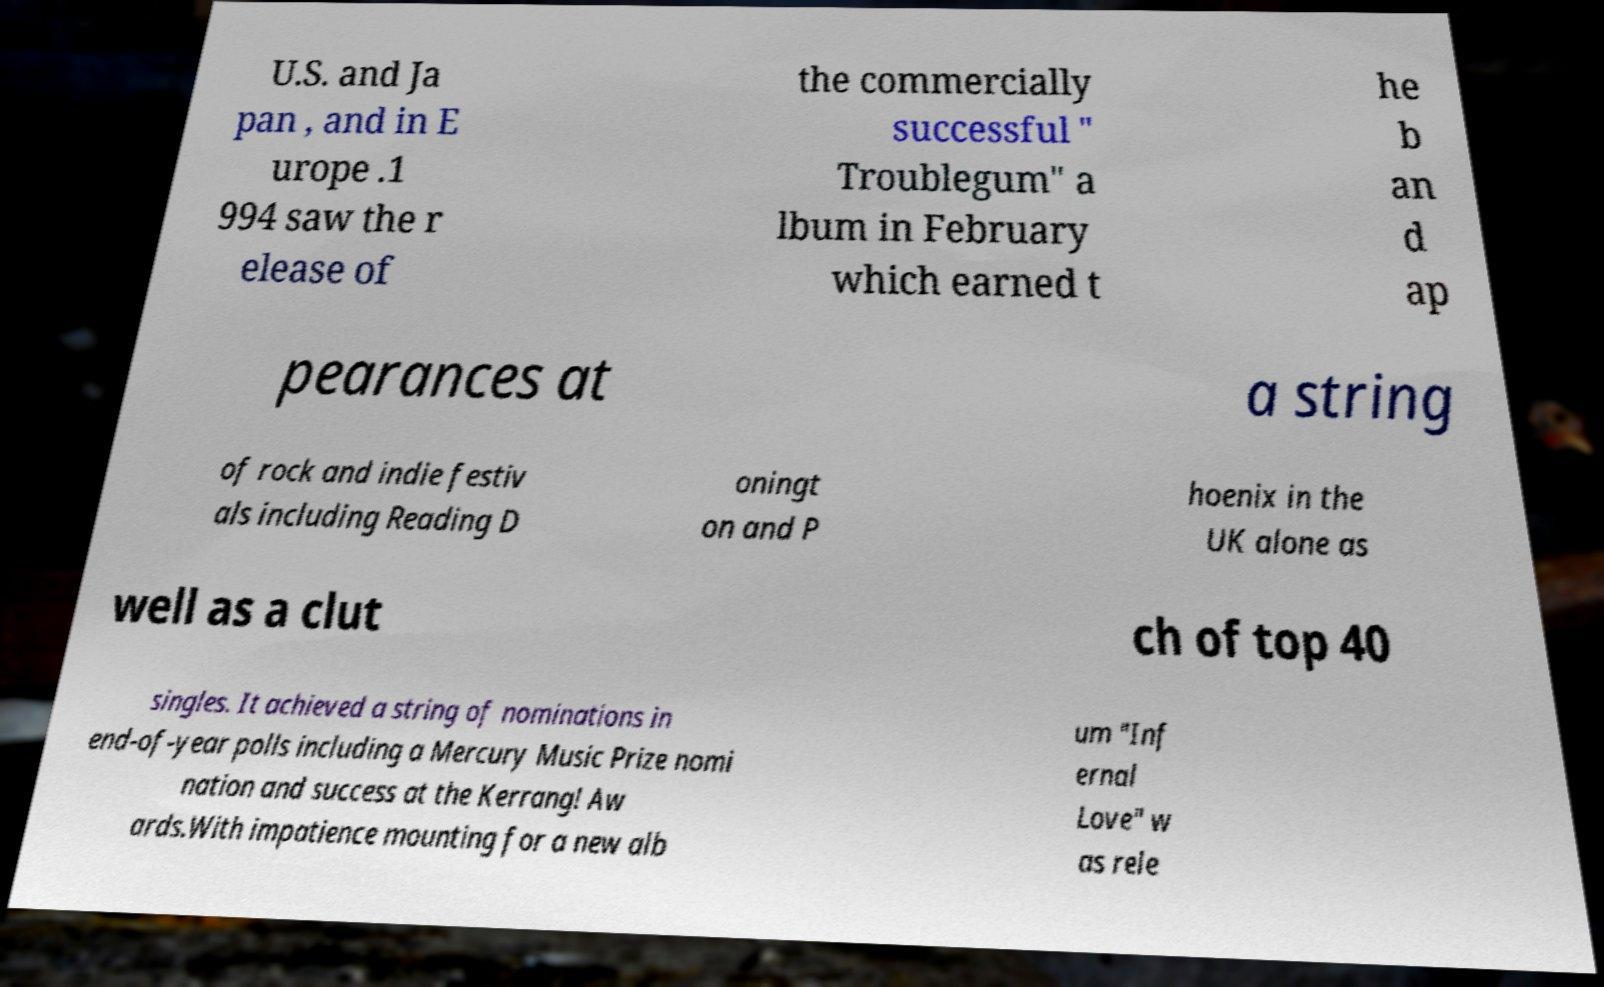I need the written content from this picture converted into text. Can you do that? U.S. and Ja pan , and in E urope .1 994 saw the r elease of the commercially successful " Troublegum" a lbum in February which earned t he b an d ap pearances at a string of rock and indie festiv als including Reading D oningt on and P hoenix in the UK alone as well as a clut ch of top 40 singles. It achieved a string of nominations in end-of-year polls including a Mercury Music Prize nomi nation and success at the Kerrang! Aw ards.With impatience mounting for a new alb um "Inf ernal Love" w as rele 